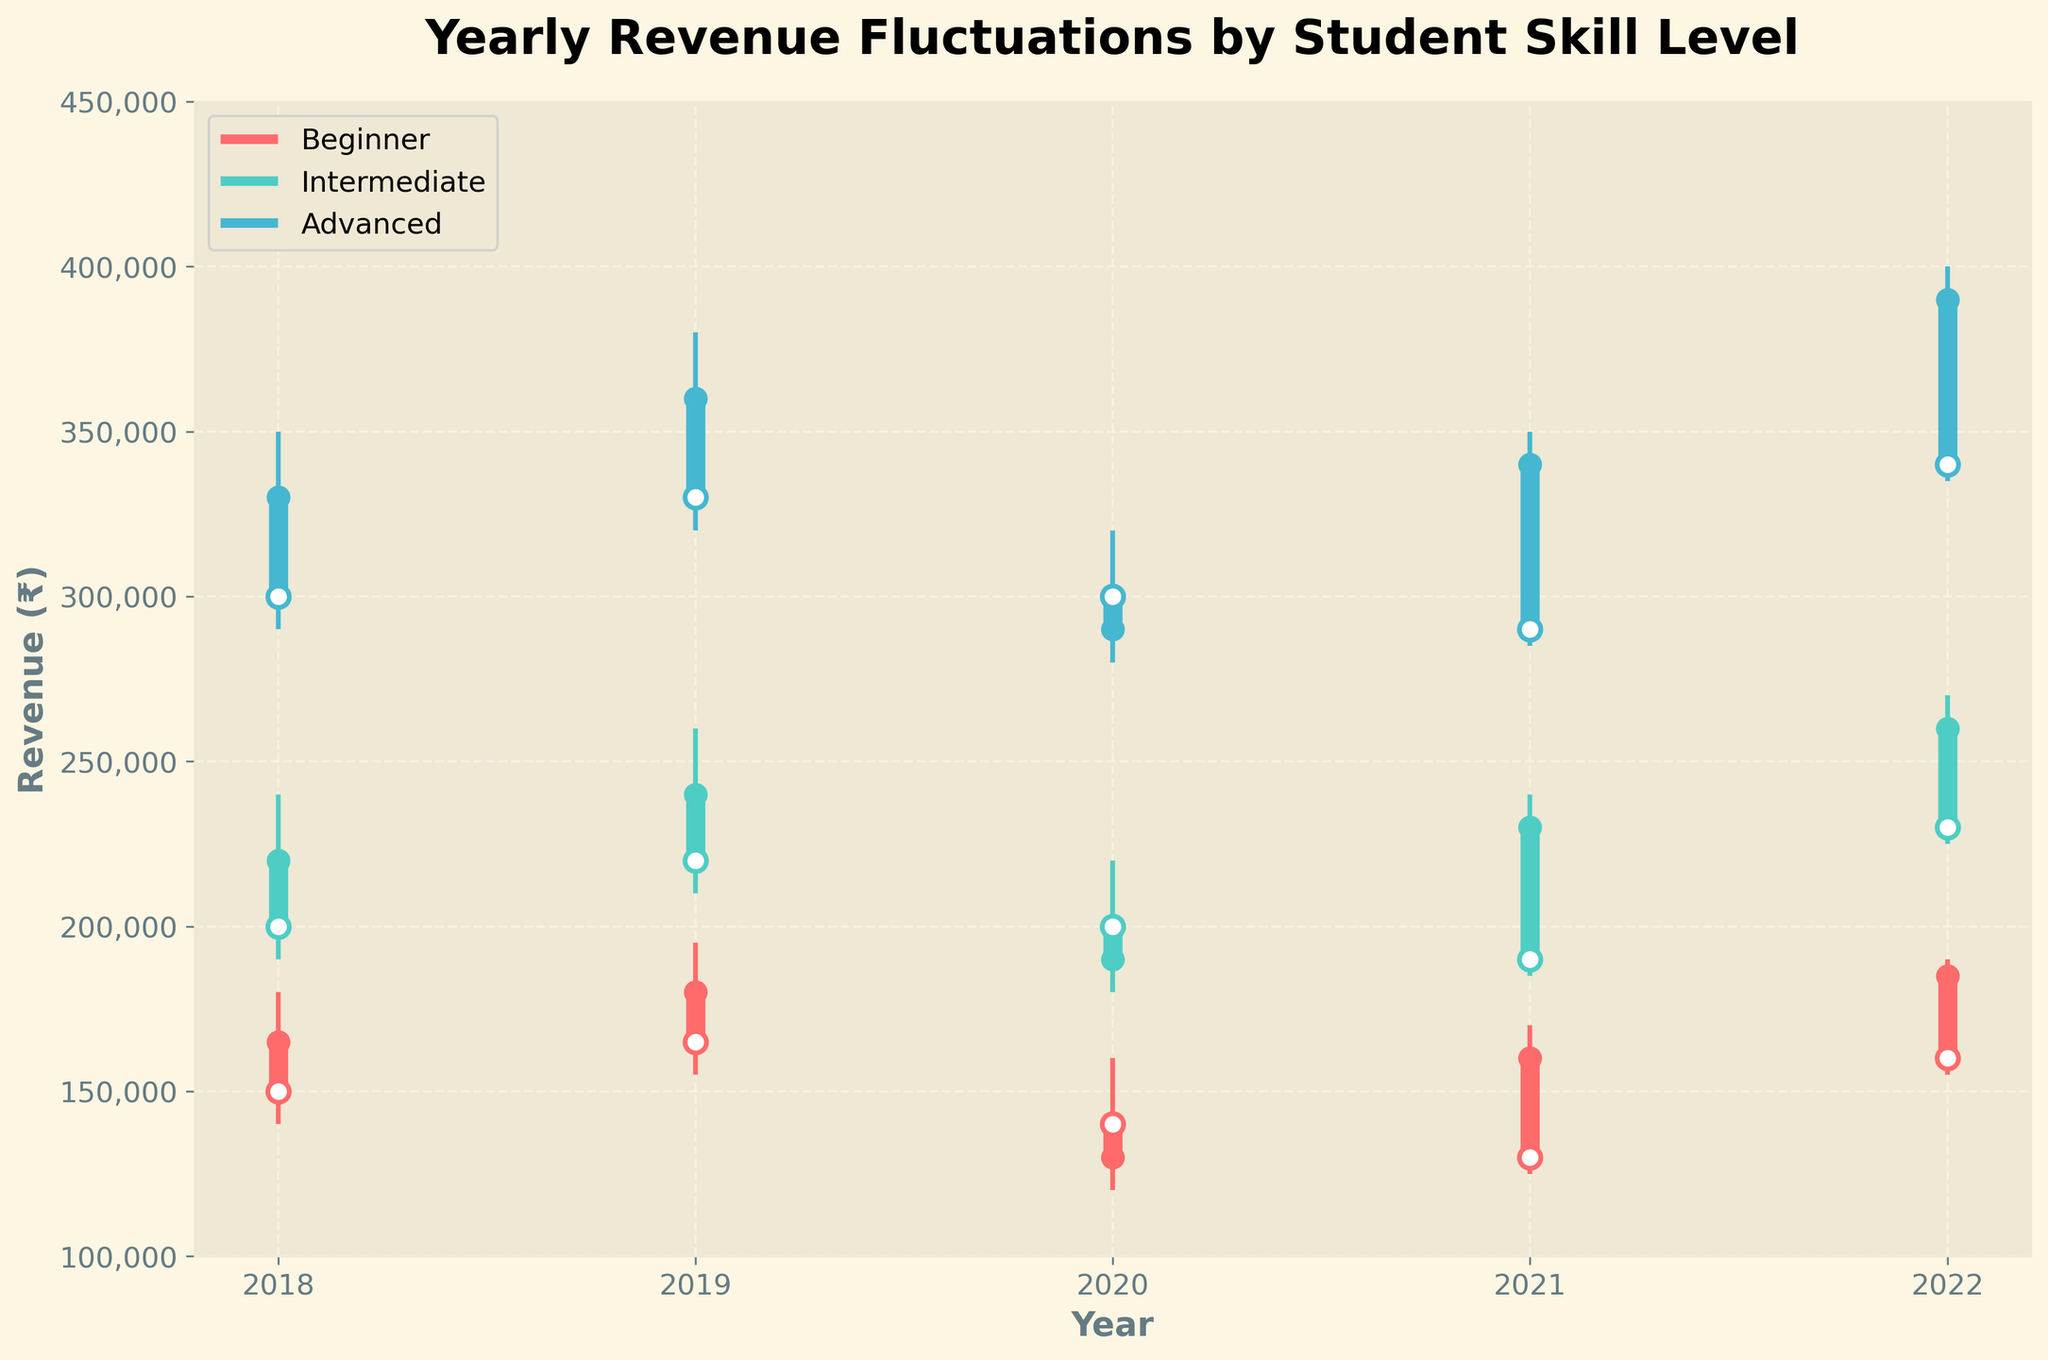What is the title of the plot? The title of the plot is located at the top of the figure. It usually provides a brief description of what the chart is about.
Answer: Yearly Revenue Fluctuations by Student Skill Level Which skill level had the highest closing revenue in 2022? To determine this, look at the closing prices for each skill level in the year 2022 and identify the highest one. The closing revenue for Beginner, Intermediate, and Advanced in 2022 are 185000, 260000, and 390000 respectively.
Answer: Advanced What was the range of revenue for Beginner level in 2020? The range of revenue is the difference between the highest and lowest values. For Beginner in 2020, the high is 160000 and the low is 120000. The range is calculated as 160000 - 120000.
Answer: 40000 Which skill level showed the largest increase in closing revenue from 2020 to 2021? Compare the closing revenues for each skill level between 2020 and 2021. Calculate the difference for Beginner (160000 - 130000 = 30000), Intermediate (230000 - 190000 = 40000), and Advanced (340000 - 290000 = 50000). The largest increase is seen in Advanced.
Answer: Advanced Between which years did the Intermediate skill level have the largest jump in high revenue? Check the high revenues for Intermediate skill level for each year and identify the largest increase between consecutive years. From 2018 to 2019 (240000 to 260000), 2019 to 2020 (260000 to 220000), 2020 to 2021 (220000 to 240000), and 2021 to 2022 (240000 to 270000). The largest jump was from 2021 to 2022 (30000).
Answer: 2021 to 2022 Was the closing revenue for Advanced level in 2018 higher or lower than the closing revenue for Intermediate level in 2021? To compare, look at the closing revenues for Advanced in 2018 (330000) and Intermediate in 2021 (230000). Determine if 330000 is higher or lower than 230000.
Answer: Higher What was the average opening revenue for Beginner skill level over the given years? Calculate the average by summing the opening revenues for Beginner over the years 2018, 2019, 2020, 2021, and 2022 and then divide by the number of years. (150000 + 165000 + 140000 + 130000 + 160000) / 5 = 745000 / 5.
Answer: 149000 How did the lowest revenue for Advanced skill level change from 2019 to 2020? Look at the lowest revenues for Advanced in 2019 (320000) and 2020 (280000) and calculate the difference. The change is 280000 - 320000, which indicates a decrease.
Answer: Decreased by 40000 Which year saw the highest high revenue for Intermediate skill level? Refer to the high revenue values for Intermediate from each year and identify the highest one. The values are 2018 (240000), 2019 (260000), 2020 (220000), 2021 (240000), and 2022 (270000).
Answer: 2022 